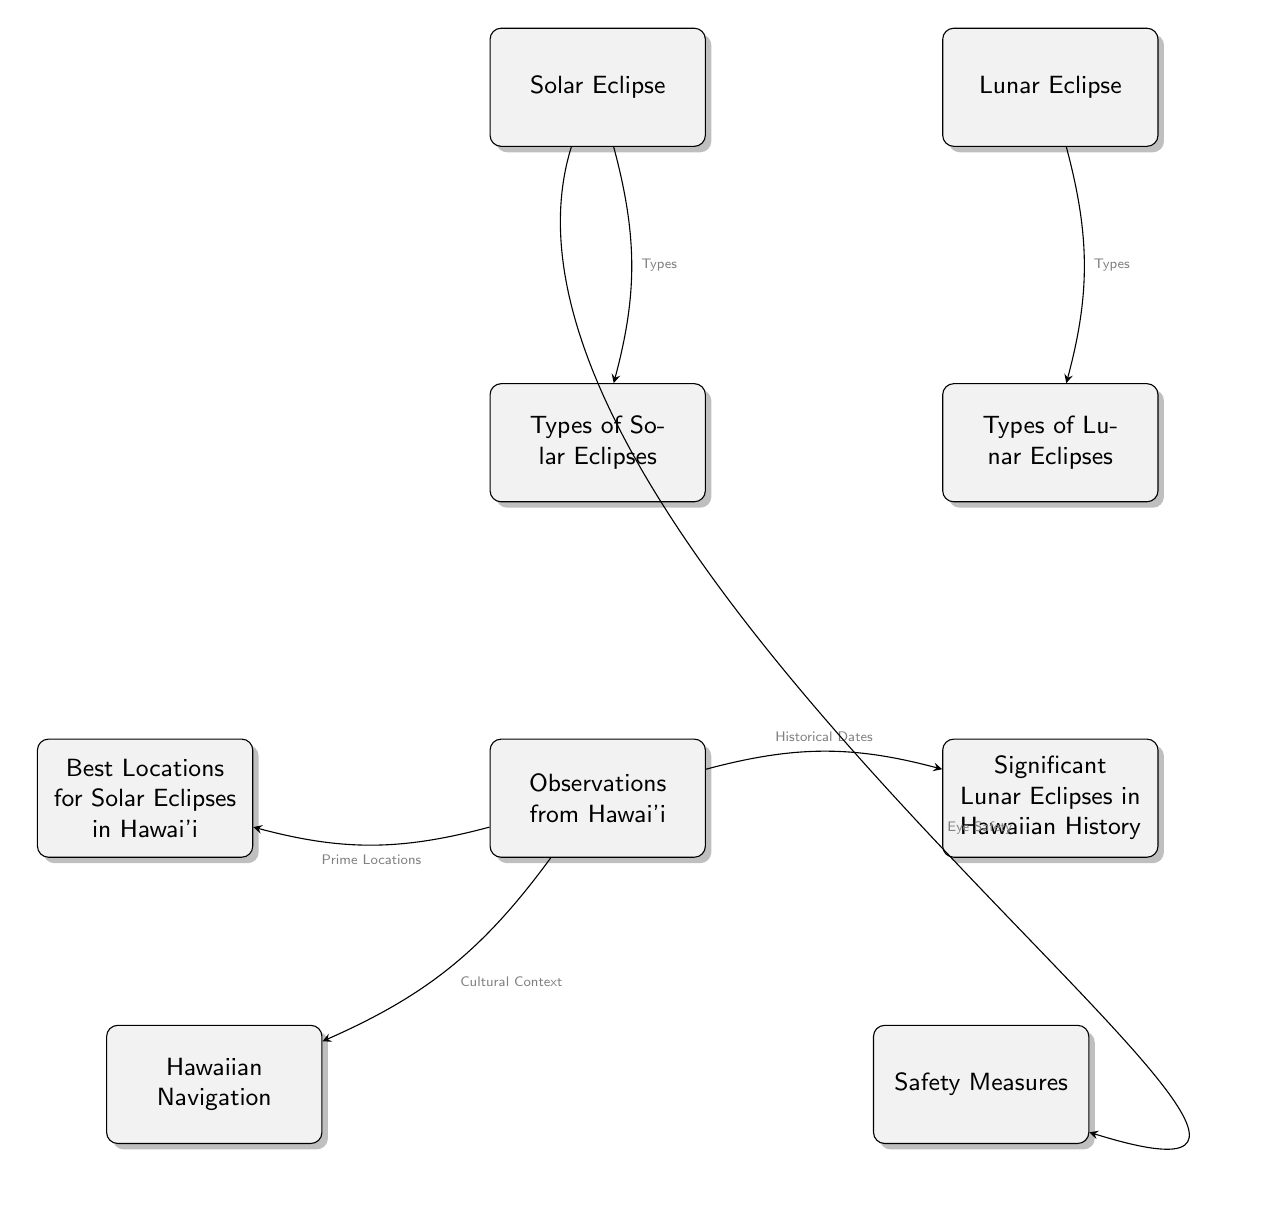What types of eclipses are shown in the diagram? The diagram shows two types of eclipses: Solar Eclipse and Lunar Eclipse, which are both prominently displayed at the top.
Answer: Solar Eclipse, Lunar Eclipse How many types of solar eclipses are indicated in the diagram? The node "Types of Solar Eclipses" is connected to the "Solar Eclipse" node, indicating that there are various types, but the exact number isn't specified in the diagram itself.
Answer: Not specified What does the arrow pointing from "Hawaiian Navigation" to "Observations from Hawai’i" indicate? The arrow indicates a relationship where Hawaiian Navigation provides cultural context to the observations of solar and lunar eclipses made in Hawai’i.
Answer: Cultural Context What are the best locations for solar eclipses in Hawai‘i according to the diagram? The node labeled "Best Locations for Solar Eclipses in Hawai'i" is linked to the "Observations from Hawai'i" node, indicating that specific locations are relevant but not listed in the diagram.
Answer: Not specified What significant historical records are included for lunar eclipses in the diagram? The node "Significant Lunar Eclipses in Hawaiian History" attached to "Observations from Hawai'i" indicates that historical contexts are addressed but does not list specific events.
Answer: Not specified What safety measures are related to solar eclipses in the diagram? The "Safety Measures" node is linked to the "Solar Eclipse" node, showing that there are important safety recommendations for solar eclipses, particularly regarding eye safety.
Answer: Eye Safety Why are types of eclipses relevant to Hawaii according to the diagram? The flow shows a connection where types of eclipses lead to observations in Hawai'i, which could suggest their significance in local cultural or historical contexts.
Answer: Observational Significance How do the types of lunar eclipses relate to the overall theme of eclipses in Hawai‘i? The types of lunar eclipses link to "Observations from Hawai'i," indicating an exploration of lunar eclipses specific to the region's cultural and historical significance.
Answer: Cultural Significance 